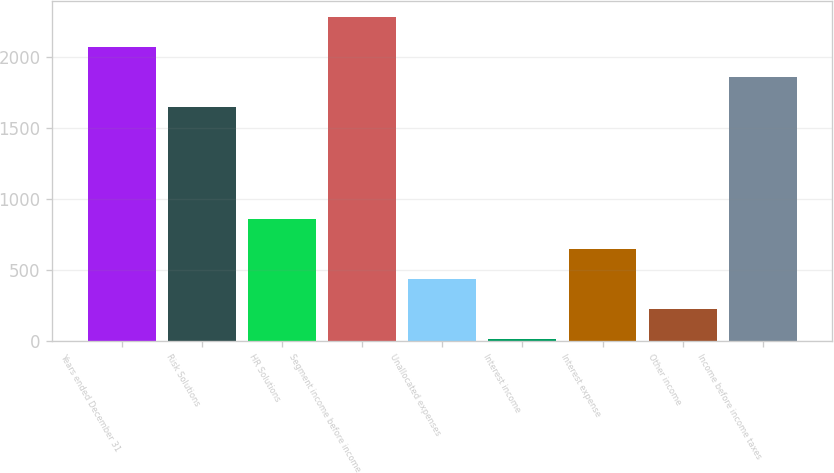Convert chart to OTSL. <chart><loc_0><loc_0><loc_500><loc_500><bar_chart><fcel>Years ended December 31<fcel>Risk Solutions<fcel>HR Solutions<fcel>Segment income before income<fcel>Unallocated expenses<fcel>Interest income<fcel>Interest expense<fcel>Other income<fcel>Income before income taxes<nl><fcel>2072.6<fcel>1648<fcel>859.2<fcel>2284.9<fcel>434.6<fcel>10<fcel>646.9<fcel>222.3<fcel>1860.3<nl></chart> 